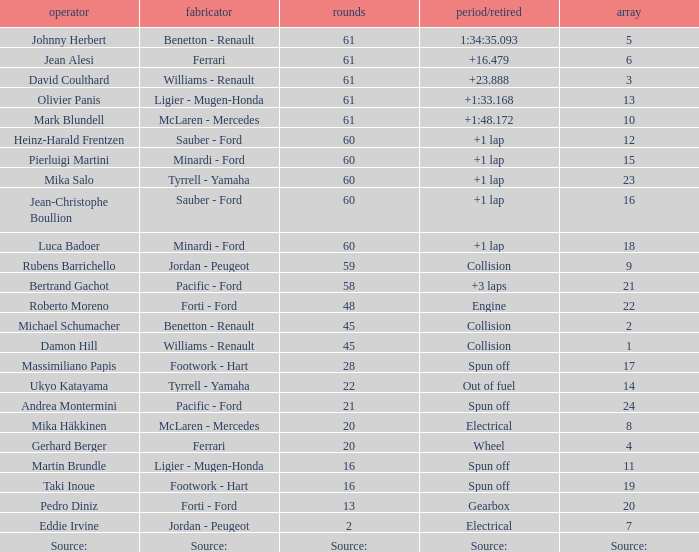What's the time/retired for a grid of 14? Out of fuel. 